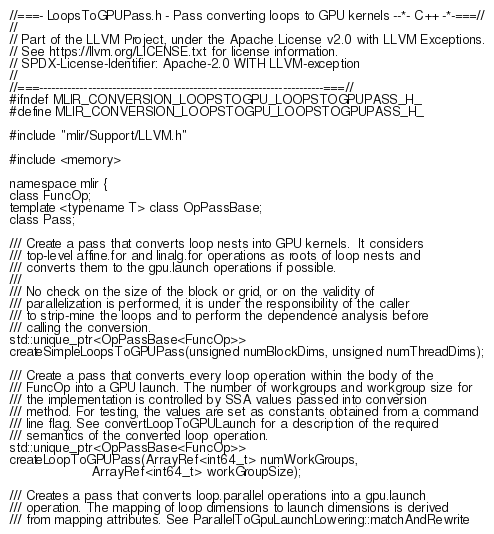<code> <loc_0><loc_0><loc_500><loc_500><_C_>//===- LoopsToGPUPass.h - Pass converting loops to GPU kernels --*- C++ -*-===//
//
// Part of the LLVM Project, under the Apache License v2.0 with LLVM Exceptions.
// See https://llvm.org/LICENSE.txt for license information.
// SPDX-License-Identifier: Apache-2.0 WITH LLVM-exception
//
//===----------------------------------------------------------------------===//
#ifndef MLIR_CONVERSION_LOOPSTOGPU_LOOPSTOGPUPASS_H_
#define MLIR_CONVERSION_LOOPSTOGPU_LOOPSTOGPUPASS_H_

#include "mlir/Support/LLVM.h"

#include <memory>

namespace mlir {
class FuncOp;
template <typename T> class OpPassBase;
class Pass;

/// Create a pass that converts loop nests into GPU kernels.  It considers
/// top-level affine.for and linalg.for operations as roots of loop nests and
/// converts them to the gpu.launch operations if possible.
///
/// No check on the size of the block or grid, or on the validity of
/// parallelization is performed, it is under the responsibility of the caller
/// to strip-mine the loops and to perform the dependence analysis before
/// calling the conversion.
std::unique_ptr<OpPassBase<FuncOp>>
createSimpleLoopsToGPUPass(unsigned numBlockDims, unsigned numThreadDims);

/// Create a pass that converts every loop operation within the body of the
/// FuncOp into a GPU launch. The number of workgroups and workgroup size for
/// the implementation is controlled by SSA values passed into conversion
/// method. For testing, the values are set as constants obtained from a command
/// line flag. See convertLoopToGPULaunch for a description of the required
/// semantics of the converted loop operation.
std::unique_ptr<OpPassBase<FuncOp>>
createLoopToGPUPass(ArrayRef<int64_t> numWorkGroups,
                    ArrayRef<int64_t> workGroupSize);

/// Creates a pass that converts loop.parallel operations into a gpu.launch
/// operation. The mapping of loop dimensions to launch dimensions is derived
/// from mapping attributes. See ParallelToGpuLaunchLowering::matchAndRewrite</code> 